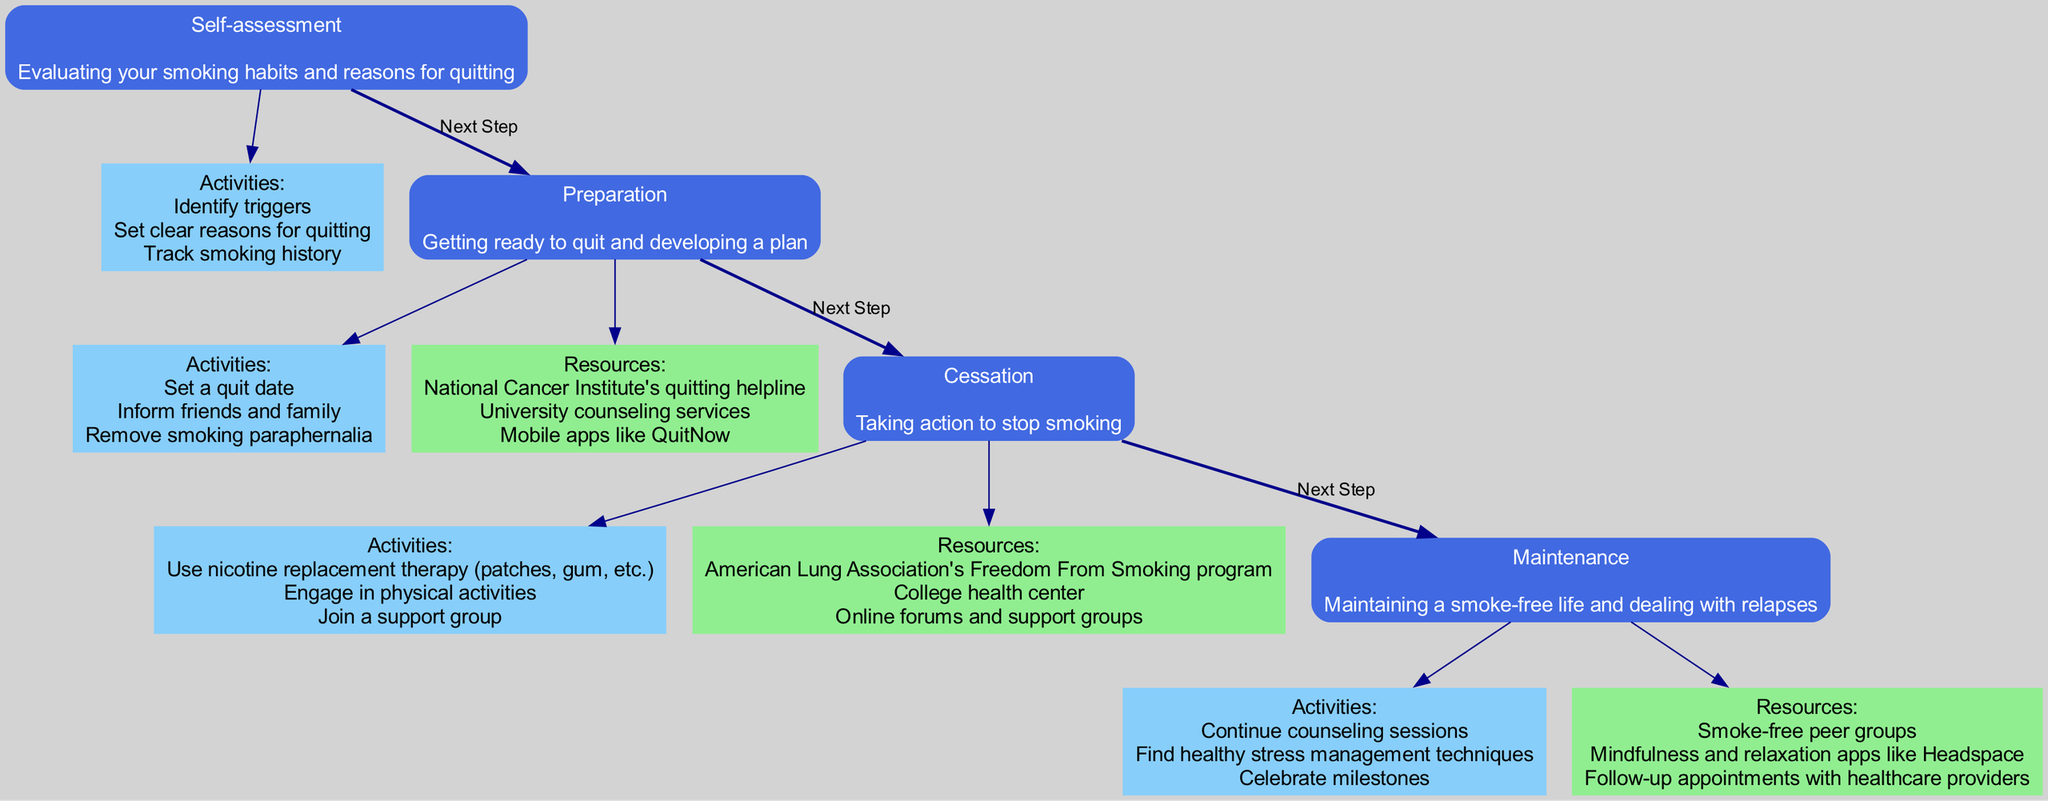What is the first step in the quitting process? The first step is labeled "Self-assessment" in the diagram, which is positioned at the topmost node.
Answer: Self-assessment What are the activities listed under the "Preparation" step? The activities under the "Preparation" step can be identified by reviewing the node connected to it. These activities include setting a quit date, informing friends and family, and removing smoking paraphernalia.
Answer: Set a quit date, inform friends and family, remove smoking paraphernalia How many steps are there in total in the quitting process? By counting the number of main step nodes in the diagram, there are four steps listed: Self-assessment, Preparation, Cessation, and Maintenance.
Answer: 4 What is the last step in the quitting process? The last step, shown at the end of the diagram flow, is labeled "Maintenance."
Answer: Maintenance Which resources are provided for the "Cessation" step? By examining the resources node linked to the "Cessation" step, we can identify the provided resources, including the American Lung Association's Freedom From Smoking program, the college health center, and online forums and support groups.
Answer: American Lung Association's Freedom From Smoking program, college health center, online forums and support groups What activity is mentioned under the "Maintenance" step? The activities associated with the "Maintenance" step can be found in the corresponding node for that step, which includes continuing counseling sessions, finding healthy stress management techniques, and celebrating milestones.
Answer: Continue counseling sessions What is the connection between the "Self-assessment" step and "Preparation" step? The connection is represented by the edge labeled "Next Step," indicating a direct progression from the "Self-assessment" step to the "Preparation" step in the diagram flow.
Answer: Next Step How does the "Preparation" step help in the quitting process? The "Preparation" step aids in quitting by enabling individuals to set a quit date, inform their support network, and remove cigarettes and paraphernalia from their environment, thus facilitating a clearer transition to cessation.
Answer: Setting a quit date, informing friends and family, removing smoking paraphernalia 